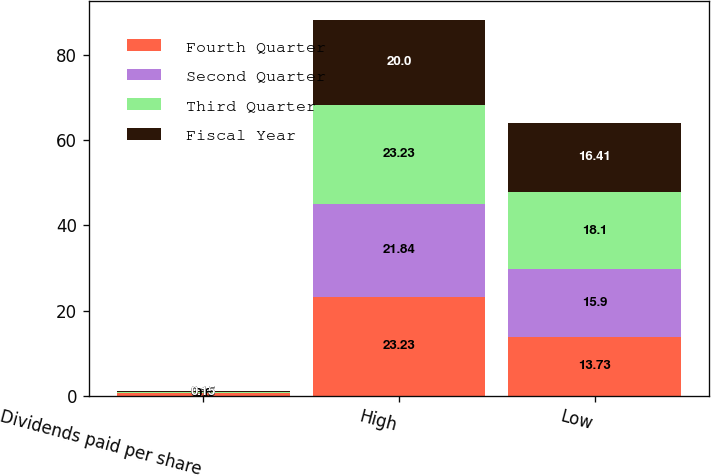Convert chart to OTSL. <chart><loc_0><loc_0><loc_500><loc_500><stacked_bar_chart><ecel><fcel>Dividends paid per share<fcel>High<fcel>Low<nl><fcel>Fourth Quarter<fcel>0.6<fcel>23.23<fcel>13.73<nl><fcel>Second Quarter<fcel>0.15<fcel>21.84<fcel>15.9<nl><fcel>Third Quarter<fcel>0.15<fcel>23.23<fcel>18.1<nl><fcel>Fiscal Year<fcel>0.15<fcel>20<fcel>16.41<nl></chart> 